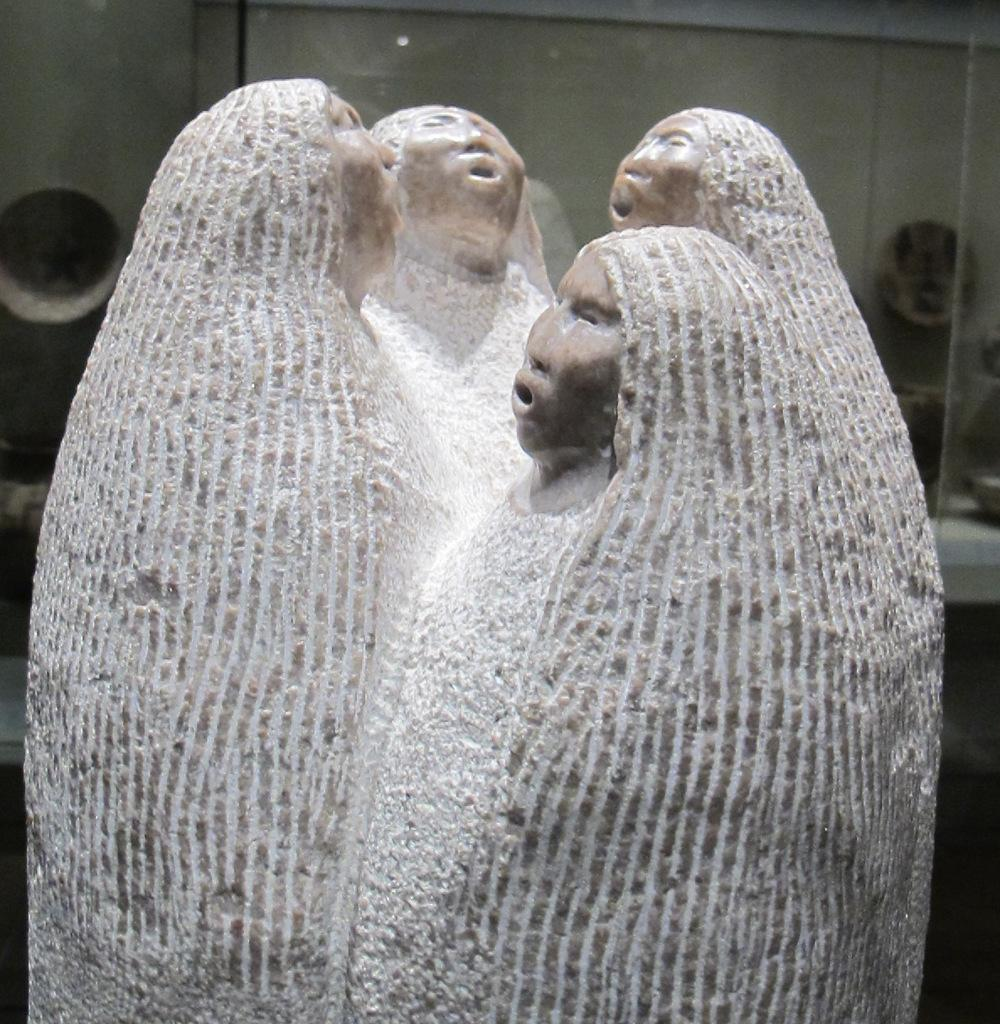What is inside the glass object in the image? There is a stone carving in a glass object. What can be seen on the surface of the glass? There is a reflection on the glass. What is visible through the glass? There are objects visible through the glass. What type of structure can be seen through the glass? There is a wall visible through the glass. How does the stone carving affect the temperature of the glass? The stone carving does not affect the temperature of the glass; it is a separate object inside the glass. 